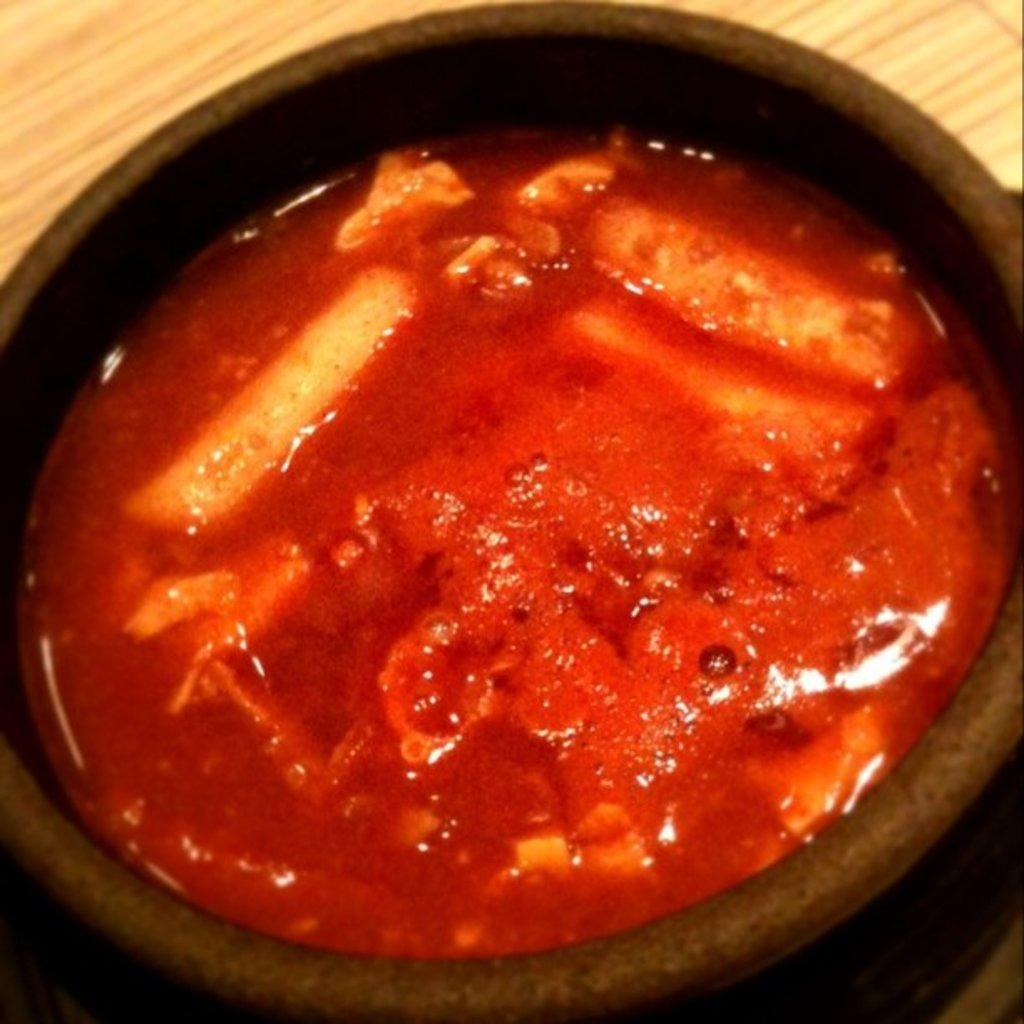What is in the bowl that is visible in the image? There is a bowl in the image. What is the substance in the bowl? The bowl contains a substance that resembles soup. What is the color of the soup in the image? The soup is red in color. How does the fire affect the group of people in the image? There is no fire or group of people present in the image; it only features a bowl with red soup. 